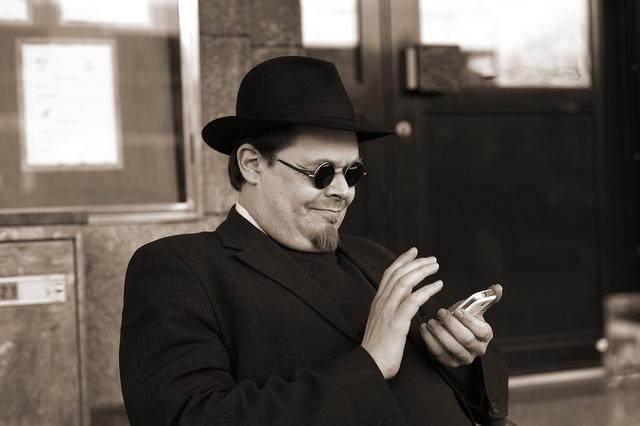What is on top of the man's hat?
Be succinct. Nothing. What is on the man's chin?
Answer briefly. Hair. What is the man reading?
Concise answer only. Phone. Could this man be religious?
Keep it brief. Yes. What is he doing?
Write a very short answer. Texting. What type of belief does this man follow?
Keep it brief. Catholic. Is the man happy?
Give a very brief answer. Yes. 